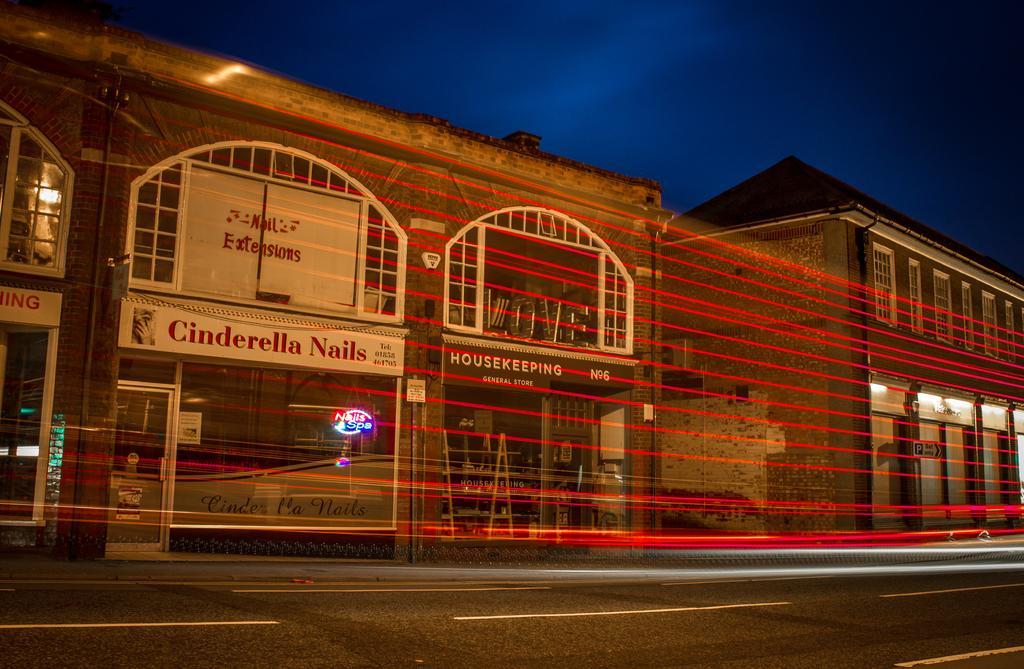Please provide a concise description of this image. In the picture I can see buildings, red color lines, road which has white lines on it and board which has something written on them. In the background I can see the sky. 